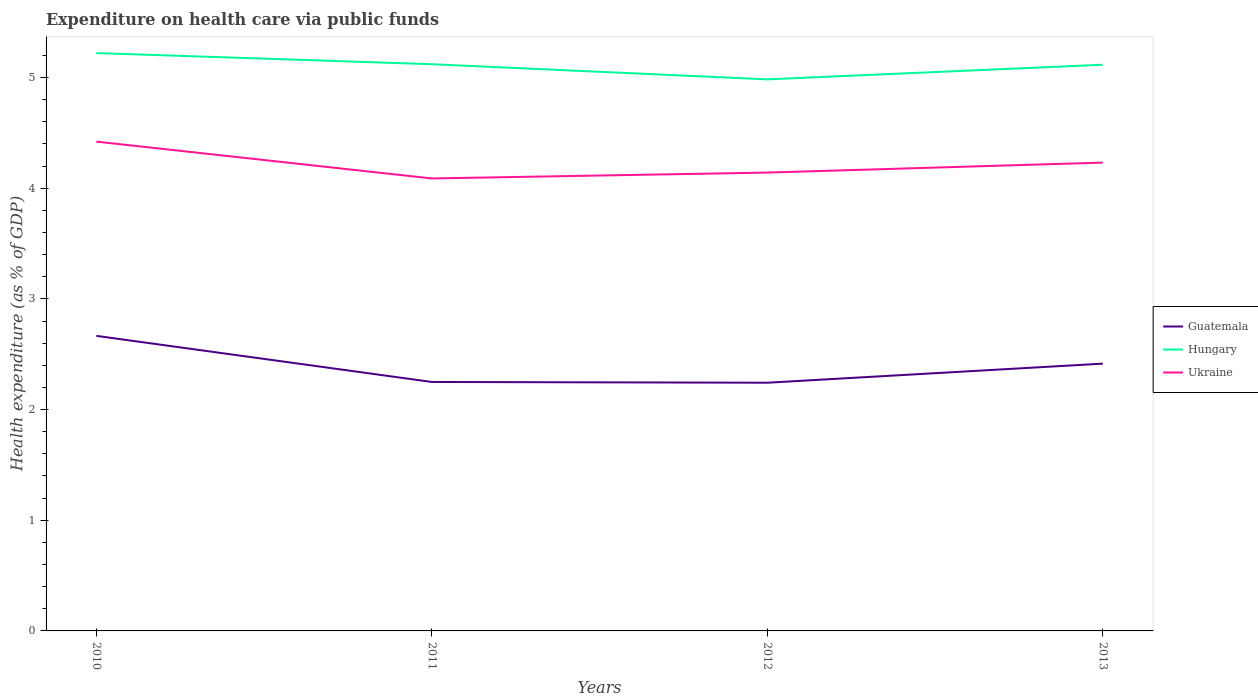Does the line corresponding to Ukraine intersect with the line corresponding to Guatemala?
Give a very brief answer. No. Is the number of lines equal to the number of legend labels?
Your answer should be very brief. Yes. Across all years, what is the maximum expenditure made on health care in Hungary?
Offer a very short reply. 4.98. In which year was the expenditure made on health care in Hungary maximum?
Your response must be concise. 2012. What is the total expenditure made on health care in Guatemala in the graph?
Your answer should be very brief. -0.17. What is the difference between the highest and the second highest expenditure made on health care in Guatemala?
Keep it short and to the point. 0.42. Is the expenditure made on health care in Ukraine strictly greater than the expenditure made on health care in Guatemala over the years?
Your answer should be compact. No. How many lines are there?
Your response must be concise. 3. How many years are there in the graph?
Make the answer very short. 4. What is the difference between two consecutive major ticks on the Y-axis?
Your response must be concise. 1. Are the values on the major ticks of Y-axis written in scientific E-notation?
Your answer should be very brief. No. Does the graph contain any zero values?
Make the answer very short. No. Does the graph contain grids?
Offer a very short reply. No. How many legend labels are there?
Provide a succinct answer. 3. How are the legend labels stacked?
Your answer should be compact. Vertical. What is the title of the graph?
Offer a very short reply. Expenditure on health care via public funds. What is the label or title of the Y-axis?
Your answer should be very brief. Health expenditure (as % of GDP). What is the Health expenditure (as % of GDP) in Guatemala in 2010?
Provide a succinct answer. 2.67. What is the Health expenditure (as % of GDP) of Hungary in 2010?
Provide a short and direct response. 5.22. What is the Health expenditure (as % of GDP) in Ukraine in 2010?
Your response must be concise. 4.42. What is the Health expenditure (as % of GDP) of Guatemala in 2011?
Give a very brief answer. 2.25. What is the Health expenditure (as % of GDP) in Hungary in 2011?
Offer a terse response. 5.12. What is the Health expenditure (as % of GDP) in Ukraine in 2011?
Make the answer very short. 4.09. What is the Health expenditure (as % of GDP) of Guatemala in 2012?
Make the answer very short. 2.24. What is the Health expenditure (as % of GDP) in Hungary in 2012?
Make the answer very short. 4.98. What is the Health expenditure (as % of GDP) of Ukraine in 2012?
Your answer should be compact. 4.14. What is the Health expenditure (as % of GDP) of Guatemala in 2013?
Ensure brevity in your answer.  2.42. What is the Health expenditure (as % of GDP) in Hungary in 2013?
Keep it short and to the point. 5.12. What is the Health expenditure (as % of GDP) in Ukraine in 2013?
Offer a very short reply. 4.23. Across all years, what is the maximum Health expenditure (as % of GDP) in Guatemala?
Provide a short and direct response. 2.67. Across all years, what is the maximum Health expenditure (as % of GDP) of Hungary?
Make the answer very short. 5.22. Across all years, what is the maximum Health expenditure (as % of GDP) of Ukraine?
Your response must be concise. 4.42. Across all years, what is the minimum Health expenditure (as % of GDP) of Guatemala?
Give a very brief answer. 2.24. Across all years, what is the minimum Health expenditure (as % of GDP) in Hungary?
Give a very brief answer. 4.98. Across all years, what is the minimum Health expenditure (as % of GDP) of Ukraine?
Provide a succinct answer. 4.09. What is the total Health expenditure (as % of GDP) in Guatemala in the graph?
Your response must be concise. 9.57. What is the total Health expenditure (as % of GDP) in Hungary in the graph?
Make the answer very short. 20.44. What is the total Health expenditure (as % of GDP) in Ukraine in the graph?
Provide a succinct answer. 16.88. What is the difference between the Health expenditure (as % of GDP) in Guatemala in 2010 and that in 2011?
Offer a very short reply. 0.42. What is the difference between the Health expenditure (as % of GDP) in Hungary in 2010 and that in 2011?
Provide a succinct answer. 0.1. What is the difference between the Health expenditure (as % of GDP) in Ukraine in 2010 and that in 2011?
Keep it short and to the point. 0.33. What is the difference between the Health expenditure (as % of GDP) of Guatemala in 2010 and that in 2012?
Make the answer very short. 0.42. What is the difference between the Health expenditure (as % of GDP) in Hungary in 2010 and that in 2012?
Ensure brevity in your answer.  0.24. What is the difference between the Health expenditure (as % of GDP) of Ukraine in 2010 and that in 2012?
Offer a terse response. 0.28. What is the difference between the Health expenditure (as % of GDP) in Guatemala in 2010 and that in 2013?
Keep it short and to the point. 0.25. What is the difference between the Health expenditure (as % of GDP) of Hungary in 2010 and that in 2013?
Your answer should be compact. 0.11. What is the difference between the Health expenditure (as % of GDP) in Ukraine in 2010 and that in 2013?
Keep it short and to the point. 0.19. What is the difference between the Health expenditure (as % of GDP) of Guatemala in 2011 and that in 2012?
Offer a very short reply. 0.01. What is the difference between the Health expenditure (as % of GDP) in Hungary in 2011 and that in 2012?
Your answer should be compact. 0.14. What is the difference between the Health expenditure (as % of GDP) in Ukraine in 2011 and that in 2012?
Your answer should be compact. -0.05. What is the difference between the Health expenditure (as % of GDP) in Guatemala in 2011 and that in 2013?
Provide a succinct answer. -0.17. What is the difference between the Health expenditure (as % of GDP) in Hungary in 2011 and that in 2013?
Offer a very short reply. 0. What is the difference between the Health expenditure (as % of GDP) in Ukraine in 2011 and that in 2013?
Keep it short and to the point. -0.14. What is the difference between the Health expenditure (as % of GDP) of Guatemala in 2012 and that in 2013?
Your answer should be very brief. -0.17. What is the difference between the Health expenditure (as % of GDP) in Hungary in 2012 and that in 2013?
Your response must be concise. -0.13. What is the difference between the Health expenditure (as % of GDP) in Ukraine in 2012 and that in 2013?
Offer a very short reply. -0.09. What is the difference between the Health expenditure (as % of GDP) in Guatemala in 2010 and the Health expenditure (as % of GDP) in Hungary in 2011?
Make the answer very short. -2.45. What is the difference between the Health expenditure (as % of GDP) of Guatemala in 2010 and the Health expenditure (as % of GDP) of Ukraine in 2011?
Provide a short and direct response. -1.42. What is the difference between the Health expenditure (as % of GDP) of Hungary in 2010 and the Health expenditure (as % of GDP) of Ukraine in 2011?
Your answer should be compact. 1.13. What is the difference between the Health expenditure (as % of GDP) in Guatemala in 2010 and the Health expenditure (as % of GDP) in Hungary in 2012?
Make the answer very short. -2.32. What is the difference between the Health expenditure (as % of GDP) in Guatemala in 2010 and the Health expenditure (as % of GDP) in Ukraine in 2012?
Give a very brief answer. -1.48. What is the difference between the Health expenditure (as % of GDP) in Hungary in 2010 and the Health expenditure (as % of GDP) in Ukraine in 2012?
Offer a terse response. 1.08. What is the difference between the Health expenditure (as % of GDP) in Guatemala in 2010 and the Health expenditure (as % of GDP) in Hungary in 2013?
Ensure brevity in your answer.  -2.45. What is the difference between the Health expenditure (as % of GDP) of Guatemala in 2010 and the Health expenditure (as % of GDP) of Ukraine in 2013?
Offer a terse response. -1.57. What is the difference between the Health expenditure (as % of GDP) of Guatemala in 2011 and the Health expenditure (as % of GDP) of Hungary in 2012?
Offer a very short reply. -2.73. What is the difference between the Health expenditure (as % of GDP) of Guatemala in 2011 and the Health expenditure (as % of GDP) of Ukraine in 2012?
Your answer should be compact. -1.89. What is the difference between the Health expenditure (as % of GDP) of Hungary in 2011 and the Health expenditure (as % of GDP) of Ukraine in 2012?
Offer a terse response. 0.98. What is the difference between the Health expenditure (as % of GDP) in Guatemala in 2011 and the Health expenditure (as % of GDP) in Hungary in 2013?
Provide a short and direct response. -2.87. What is the difference between the Health expenditure (as % of GDP) in Guatemala in 2011 and the Health expenditure (as % of GDP) in Ukraine in 2013?
Make the answer very short. -1.98. What is the difference between the Health expenditure (as % of GDP) of Hungary in 2011 and the Health expenditure (as % of GDP) of Ukraine in 2013?
Your answer should be compact. 0.89. What is the difference between the Health expenditure (as % of GDP) of Guatemala in 2012 and the Health expenditure (as % of GDP) of Hungary in 2013?
Offer a very short reply. -2.87. What is the difference between the Health expenditure (as % of GDP) in Guatemala in 2012 and the Health expenditure (as % of GDP) in Ukraine in 2013?
Offer a very short reply. -1.99. What is the difference between the Health expenditure (as % of GDP) of Hungary in 2012 and the Health expenditure (as % of GDP) of Ukraine in 2013?
Offer a terse response. 0.75. What is the average Health expenditure (as % of GDP) of Guatemala per year?
Give a very brief answer. 2.39. What is the average Health expenditure (as % of GDP) of Hungary per year?
Provide a short and direct response. 5.11. What is the average Health expenditure (as % of GDP) in Ukraine per year?
Your answer should be compact. 4.22. In the year 2010, what is the difference between the Health expenditure (as % of GDP) of Guatemala and Health expenditure (as % of GDP) of Hungary?
Your response must be concise. -2.56. In the year 2010, what is the difference between the Health expenditure (as % of GDP) in Guatemala and Health expenditure (as % of GDP) in Ukraine?
Your answer should be very brief. -1.76. In the year 2010, what is the difference between the Health expenditure (as % of GDP) of Hungary and Health expenditure (as % of GDP) of Ukraine?
Your answer should be compact. 0.8. In the year 2011, what is the difference between the Health expenditure (as % of GDP) in Guatemala and Health expenditure (as % of GDP) in Hungary?
Keep it short and to the point. -2.87. In the year 2011, what is the difference between the Health expenditure (as % of GDP) in Guatemala and Health expenditure (as % of GDP) in Ukraine?
Your answer should be compact. -1.84. In the year 2011, what is the difference between the Health expenditure (as % of GDP) of Hungary and Health expenditure (as % of GDP) of Ukraine?
Your response must be concise. 1.03. In the year 2012, what is the difference between the Health expenditure (as % of GDP) in Guatemala and Health expenditure (as % of GDP) in Hungary?
Provide a short and direct response. -2.74. In the year 2012, what is the difference between the Health expenditure (as % of GDP) of Guatemala and Health expenditure (as % of GDP) of Ukraine?
Your response must be concise. -1.9. In the year 2012, what is the difference between the Health expenditure (as % of GDP) in Hungary and Health expenditure (as % of GDP) in Ukraine?
Keep it short and to the point. 0.84. In the year 2013, what is the difference between the Health expenditure (as % of GDP) of Guatemala and Health expenditure (as % of GDP) of Hungary?
Your response must be concise. -2.7. In the year 2013, what is the difference between the Health expenditure (as % of GDP) in Guatemala and Health expenditure (as % of GDP) in Ukraine?
Offer a terse response. -1.82. In the year 2013, what is the difference between the Health expenditure (as % of GDP) of Hungary and Health expenditure (as % of GDP) of Ukraine?
Keep it short and to the point. 0.88. What is the ratio of the Health expenditure (as % of GDP) in Guatemala in 2010 to that in 2011?
Your response must be concise. 1.19. What is the ratio of the Health expenditure (as % of GDP) of Hungary in 2010 to that in 2011?
Your response must be concise. 1.02. What is the ratio of the Health expenditure (as % of GDP) in Ukraine in 2010 to that in 2011?
Provide a succinct answer. 1.08. What is the ratio of the Health expenditure (as % of GDP) of Guatemala in 2010 to that in 2012?
Ensure brevity in your answer.  1.19. What is the ratio of the Health expenditure (as % of GDP) of Hungary in 2010 to that in 2012?
Provide a succinct answer. 1.05. What is the ratio of the Health expenditure (as % of GDP) in Ukraine in 2010 to that in 2012?
Make the answer very short. 1.07. What is the ratio of the Health expenditure (as % of GDP) in Guatemala in 2010 to that in 2013?
Your response must be concise. 1.1. What is the ratio of the Health expenditure (as % of GDP) of Hungary in 2010 to that in 2013?
Provide a short and direct response. 1.02. What is the ratio of the Health expenditure (as % of GDP) of Ukraine in 2010 to that in 2013?
Make the answer very short. 1.04. What is the ratio of the Health expenditure (as % of GDP) in Guatemala in 2011 to that in 2012?
Make the answer very short. 1. What is the ratio of the Health expenditure (as % of GDP) in Hungary in 2011 to that in 2012?
Ensure brevity in your answer.  1.03. What is the ratio of the Health expenditure (as % of GDP) in Ukraine in 2011 to that in 2012?
Keep it short and to the point. 0.99. What is the ratio of the Health expenditure (as % of GDP) of Guatemala in 2011 to that in 2013?
Your answer should be very brief. 0.93. What is the ratio of the Health expenditure (as % of GDP) of Ukraine in 2011 to that in 2013?
Provide a succinct answer. 0.97. What is the ratio of the Health expenditure (as % of GDP) of Hungary in 2012 to that in 2013?
Make the answer very short. 0.97. What is the ratio of the Health expenditure (as % of GDP) in Ukraine in 2012 to that in 2013?
Your answer should be compact. 0.98. What is the difference between the highest and the second highest Health expenditure (as % of GDP) of Guatemala?
Give a very brief answer. 0.25. What is the difference between the highest and the second highest Health expenditure (as % of GDP) in Hungary?
Keep it short and to the point. 0.1. What is the difference between the highest and the second highest Health expenditure (as % of GDP) of Ukraine?
Provide a short and direct response. 0.19. What is the difference between the highest and the lowest Health expenditure (as % of GDP) of Guatemala?
Your response must be concise. 0.42. What is the difference between the highest and the lowest Health expenditure (as % of GDP) of Hungary?
Offer a very short reply. 0.24. What is the difference between the highest and the lowest Health expenditure (as % of GDP) in Ukraine?
Your response must be concise. 0.33. 